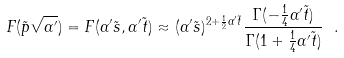<formula> <loc_0><loc_0><loc_500><loc_500>F ( \tilde { p } \sqrt { \alpha ^ { \prime } } ) = F ( \alpha ^ { \prime } \tilde { s } , \alpha ^ { \prime } \tilde { t } ) \approx ( \alpha ^ { \prime } \tilde { s } ) ^ { 2 + \frac { 1 } { 2 } \alpha ^ { \prime } \tilde { t } } \frac { \Gamma ( - \frac { 1 } { 4 } \alpha ^ { \prime } \tilde { t } ) } { \Gamma ( 1 + \frac { 1 } { 4 } \alpha ^ { \prime } \tilde { t } ) } \ .</formula> 